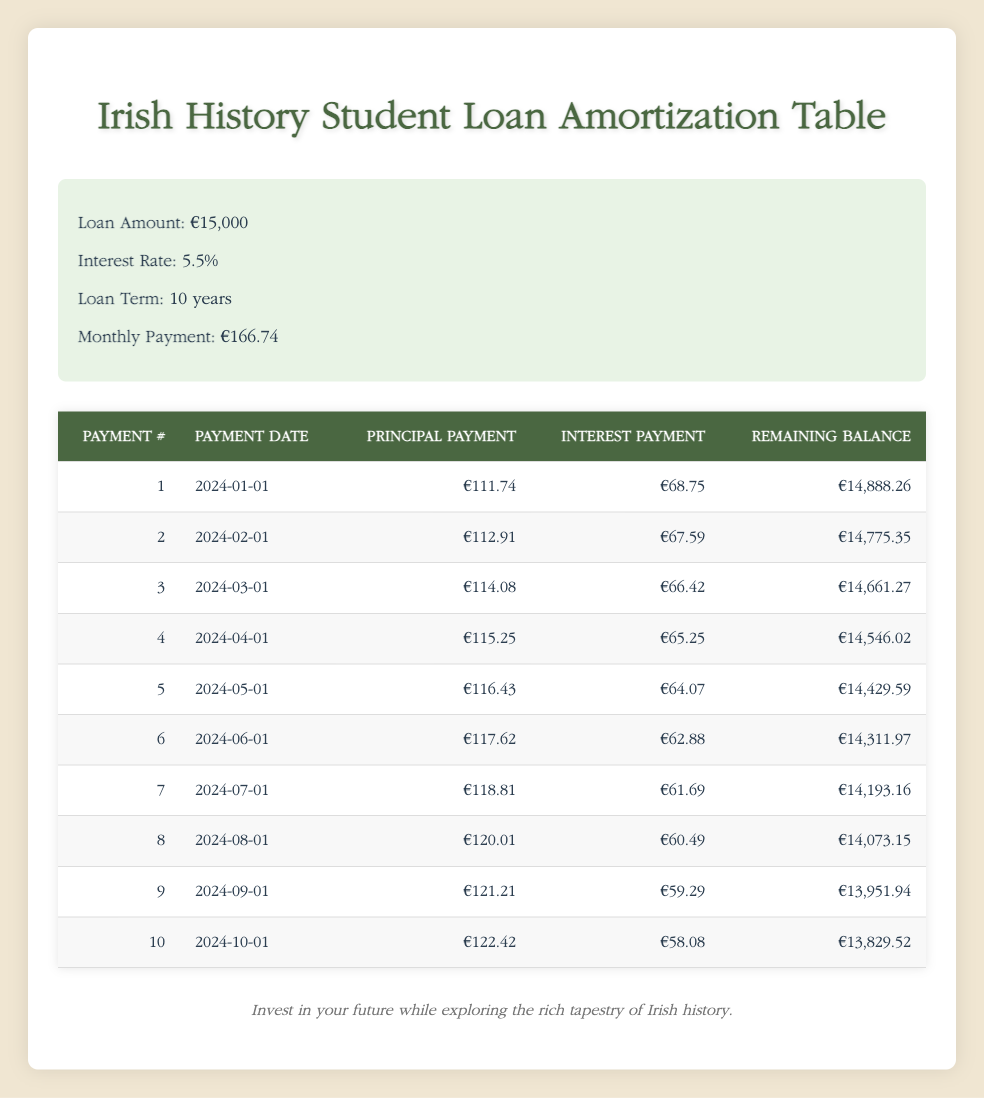What is the total amount of principal paid after the first two payments? The principal payments for the first two months are €111.74 and €112.91. Adding these together gives €111.74 + €112.91 = €224.65.
Answer: €224.65 What is the remaining balance after the sixth payment? Referring to the table, after the sixth payment, the remaining balance shows €14,311.97.
Answer: €14,311.97 Is the interest payment for the fourth month greater than €65? The interest payment for the fourth month is €65.25, which is greater than €65. Thus, the statement is true.
Answer: Yes What is the total interest paid in the first three payments? The interest payments for the first three months are €68.75, €67.59, and €66.42. Adding these gives €68.75 + €67.59 + €66.42 = €202.76.
Answer: €202.76 How much more is the principal payment in the tenth payment compared to the first payment? The principal payment in the first month is €111.74 and in the tenth month is €122.42. The difference is €122.42 - €111.74 = €10.68.
Answer: €10.68 What percentage of the monthly payment is made up of principal in the fifth month? The principal payment in the fifth month is €116.43 and the total monthly payment is €166.74. The percentage is (€116.43 / €166.74) * 100 = 69.7%.
Answer: 69.7% What is the average principal payment over the first ten payments? The principal payments for the first ten months must be added together and divided by ten. The sum is (111.74 + 112.91 + 114.08 + 115.25 + 116.43 + 117.62 + 118.81 + 120.01 + 121.21 + 122.42) = 1,401.54, so the average is 1,401.54 / 10 = 140.15.
Answer: €140.15 Which month has the highest interest payment? By examining the interest payment amounts listed, the highest amount is €68.75 from the first month.
Answer: First month What is the remaining balance after the third payment? Referring to the table, after the third payment, the remaining balance is €14,661.27.
Answer: €14,661.27 